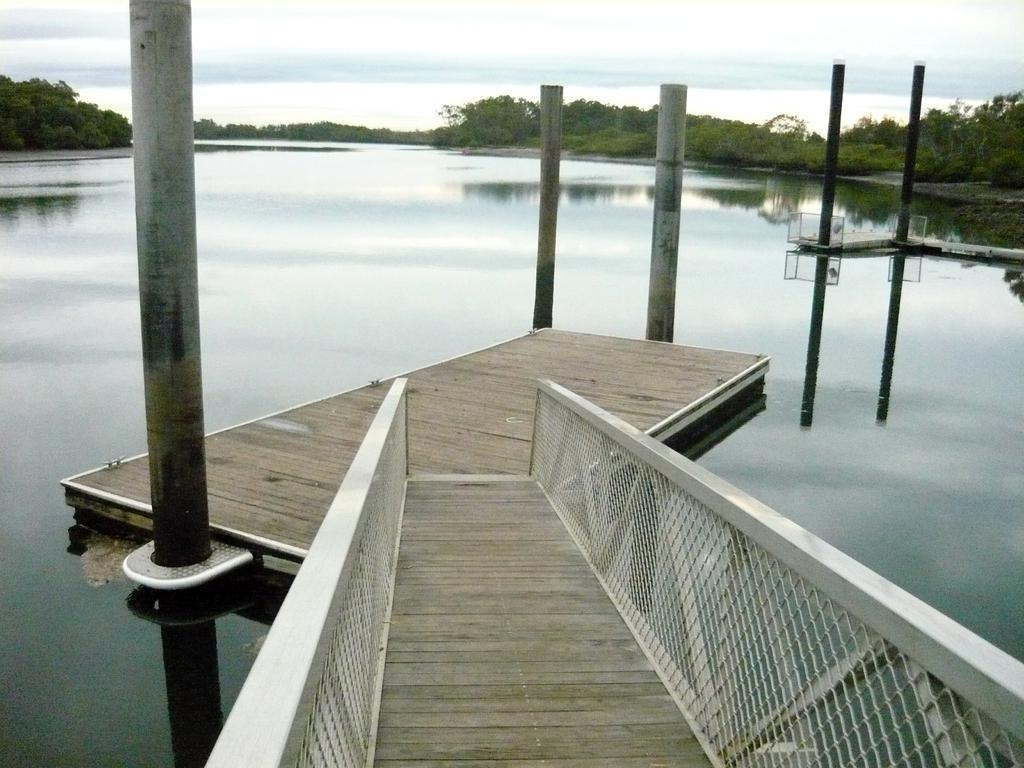Could you give a brief overview of what you see in this image? In this image I can see a platform in the centre. In the background I can see number of poles, water, number of trees and the sky. 